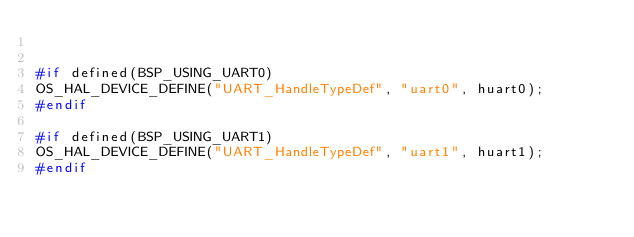<code> <loc_0><loc_0><loc_500><loc_500><_C_>

#if defined(BSP_USING_UART0)
OS_HAL_DEVICE_DEFINE("UART_HandleTypeDef", "uart0", huart0);
#endif

#if defined(BSP_USING_UART1)
OS_HAL_DEVICE_DEFINE("UART_HandleTypeDef", "uart1", huart1);
#endif

</code> 